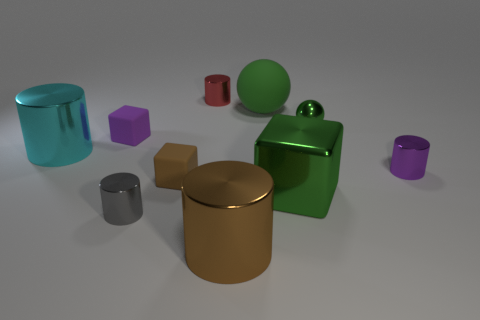Is there any other thing that is the same shape as the small brown matte thing?
Give a very brief answer. Yes. What color is the other big metallic thing that is the same shape as the big brown metallic thing?
Ensure brevity in your answer.  Cyan. Do the cyan cylinder and the gray metal object have the same size?
Make the answer very short. No. How many other things are the same size as the red cylinder?
Offer a very short reply. 5. How many objects are either big metallic cylinders that are to the right of the small purple rubber object or tiny things left of the big block?
Offer a terse response. 5. There is a green metallic thing that is the same size as the gray cylinder; what shape is it?
Keep it short and to the point. Sphere. The gray thing that is the same material as the big cyan thing is what size?
Give a very brief answer. Small. Do the cyan shiny object and the red metal object have the same shape?
Your answer should be compact. Yes. What color is the ball that is the same size as the purple shiny cylinder?
Offer a terse response. Green. There is a brown shiny thing that is the same shape as the small red metallic thing; what is its size?
Offer a terse response. Large. 